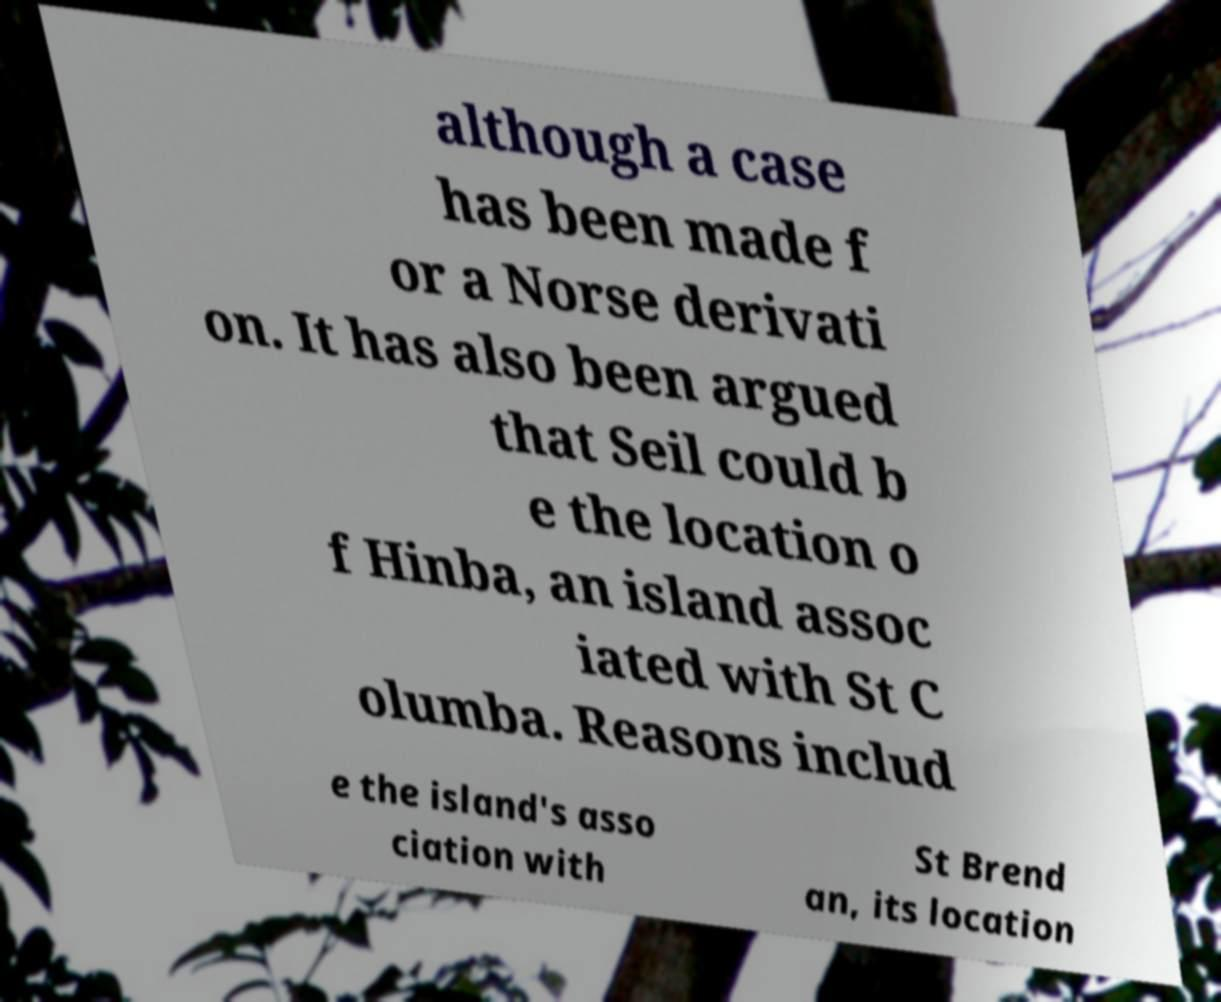Please read and relay the text visible in this image. What does it say? although a case has been made f or a Norse derivati on. It has also been argued that Seil could b e the location o f Hinba, an island assoc iated with St C olumba. Reasons includ e the island's asso ciation with St Brend an, its location 